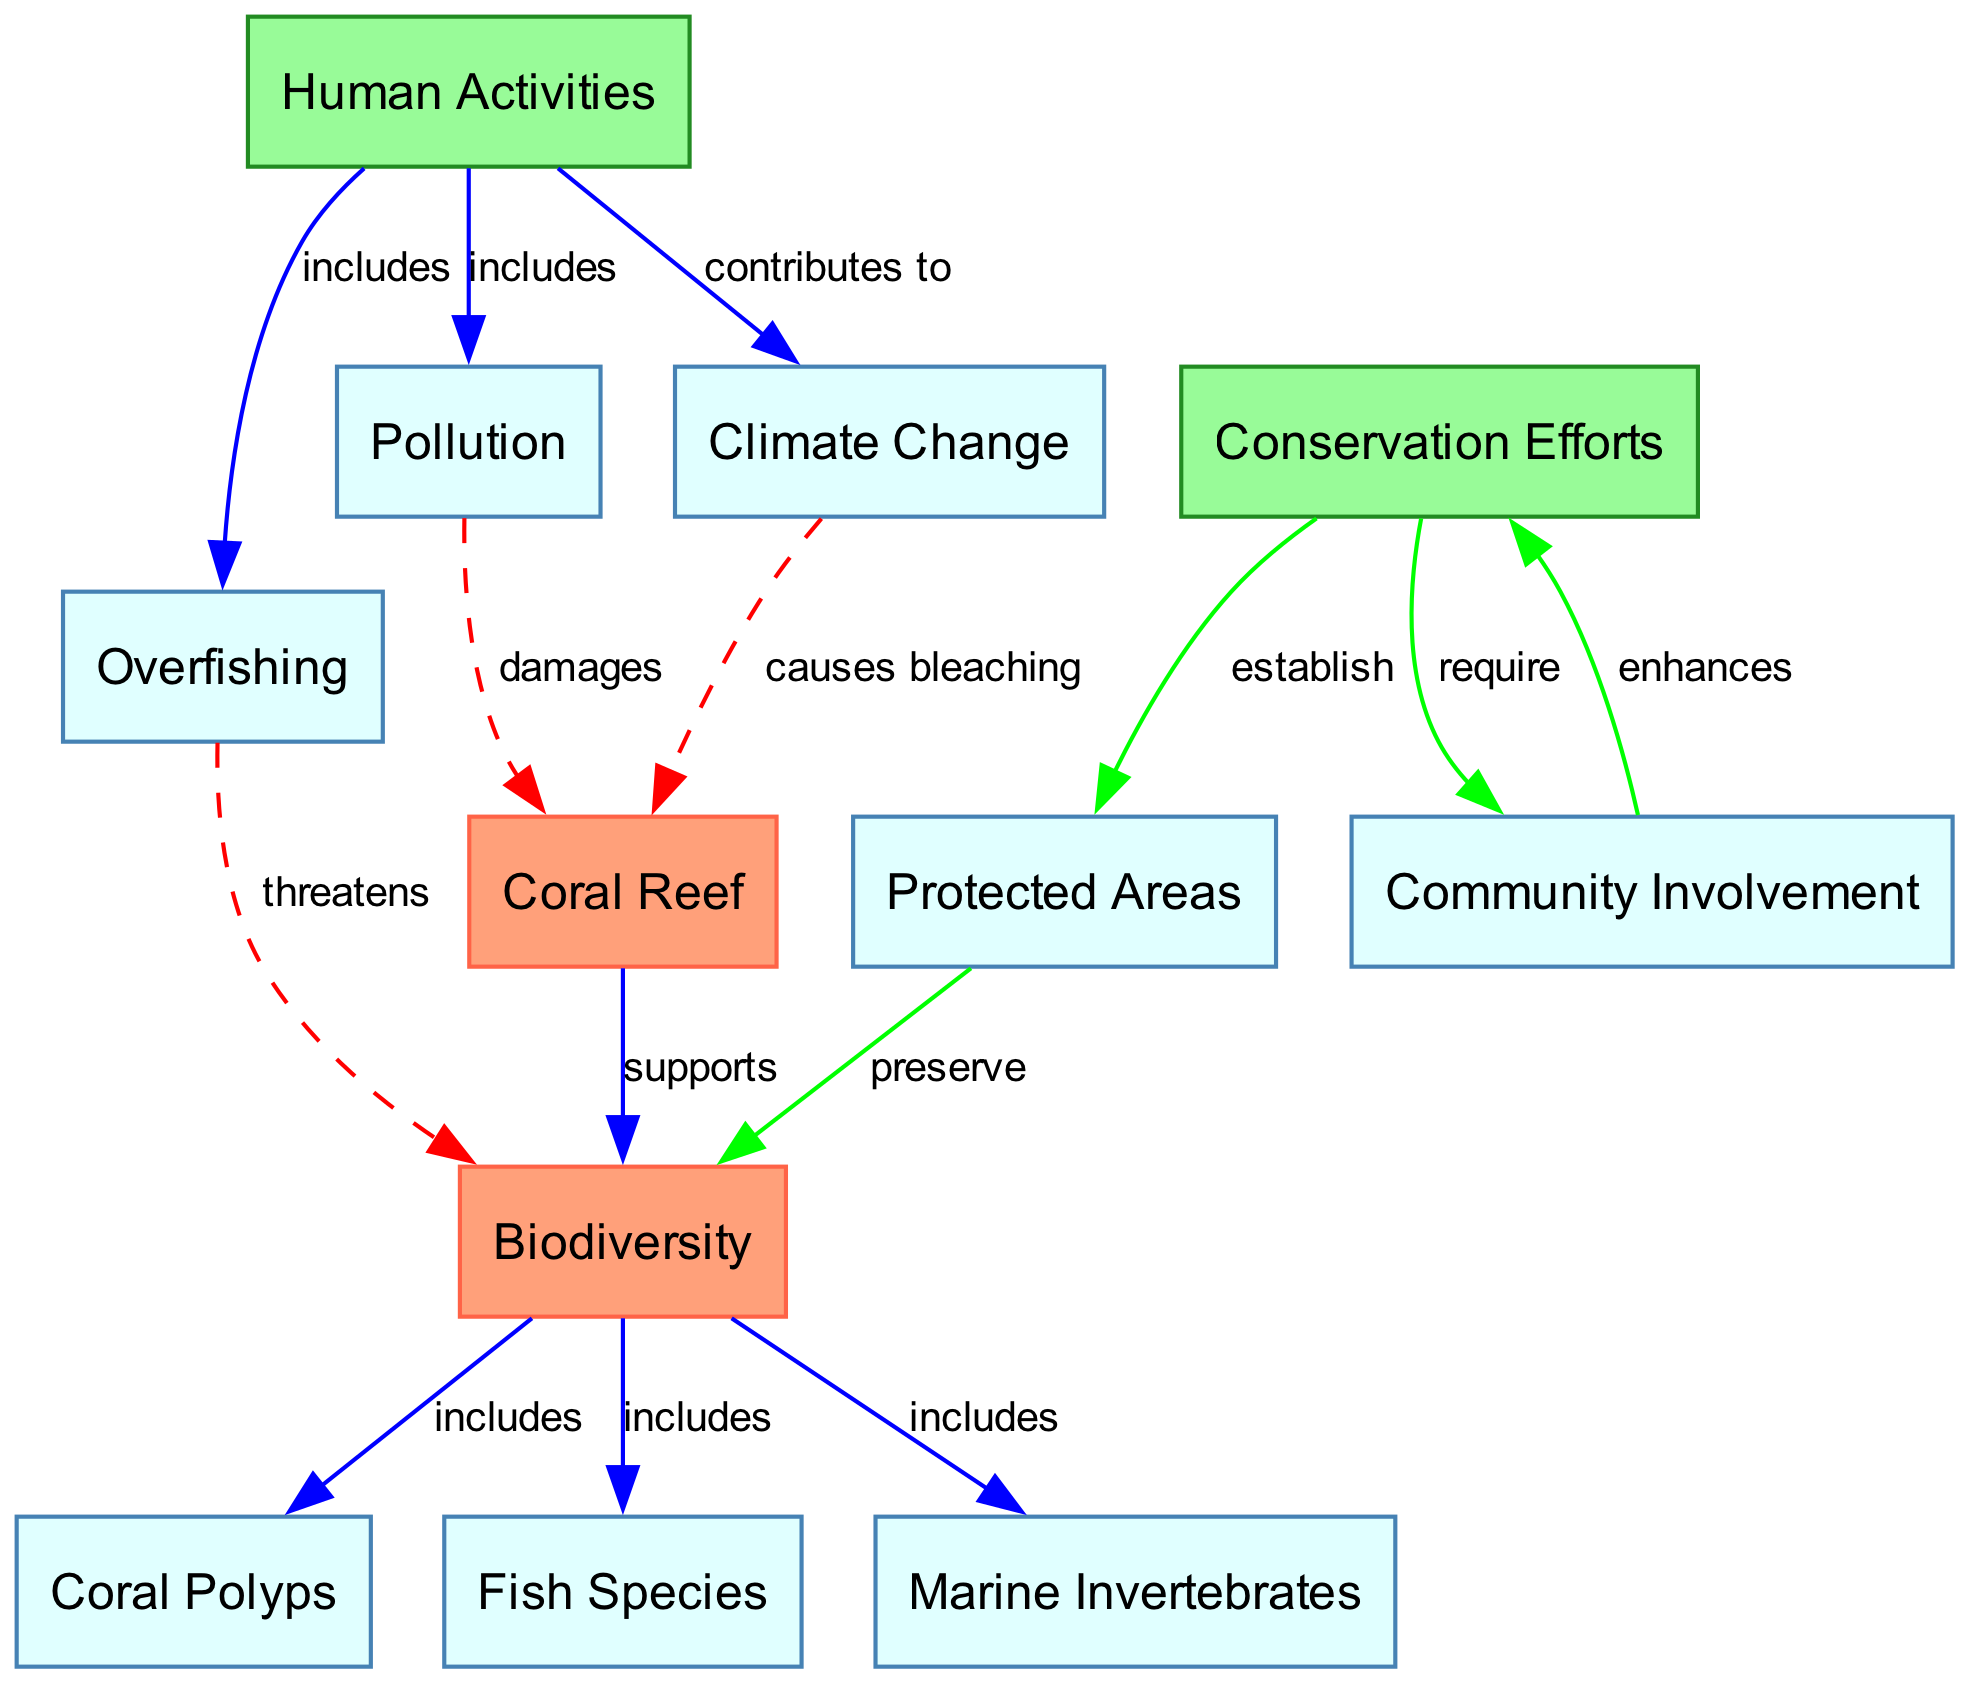What is the main entity represented in the diagram? The diagram centers around the "Coral Reef," which is depicted at the top as a primary element. It is the starting point of the ecosystem and the foundation for the relationships shown in the diagram.
Answer: Coral Reef How many species are included in the biodiversity? The diagram specifies three groups that make up the biodiversity: "Coral Polyps," "Fish Species," and "Marine Invertebrates." Therefore, the total number of groups is three.
Answer: Three What activity threatens biodiversity? The diagram shows a direct connection from "Overfishing" to "Biodiversity," indicating that overfishing poses a threat to the diversity of life within the reef system.
Answer: Overfishing What damages the coral reef according to the diagram? There is an edge labeled "damages" that connects "Pollution" to "Coral Reef," indicating that pollution is a significant cause of damage to the coral ecosystem.
Answer: Pollution Which human activity contributes to climate change? The diagram illustrates a flow from "Human Activities" to "Climate Change," specifically identifying that human activities contribute to climate change as represented in this relationship.
Answer: Human Activities What is one of the benefits of conservation efforts? The diagram indicates that conservation efforts establish "Protected Areas," which play a critical role in preserving biodiversity within the coral reef ecosystem, showing a positive relationship.
Answer: Protected Areas How does community involvement affect conservation efforts? The diagram demonstrates that "Community Involvement" enhances "Conservation Efforts," highlighting the importance of local participation in boosting conservation initiatives for coral reefs.
Answer: Enhances What causes coral bleaching? Through the diagram, it can be seen that "Climate Change" causes "Coral Bleaching," showing a direct relationship and indicating that this environmental change significantly impacts coral health.
Answer: Climate Change How do protected areas relate to biodiversity? The diagram establishes a connection where "Protected Areas" preserve "Biodiversity," thus emphasizing the essential role of protected regions in maintaining diverse marine life.
Answer: Preserve 